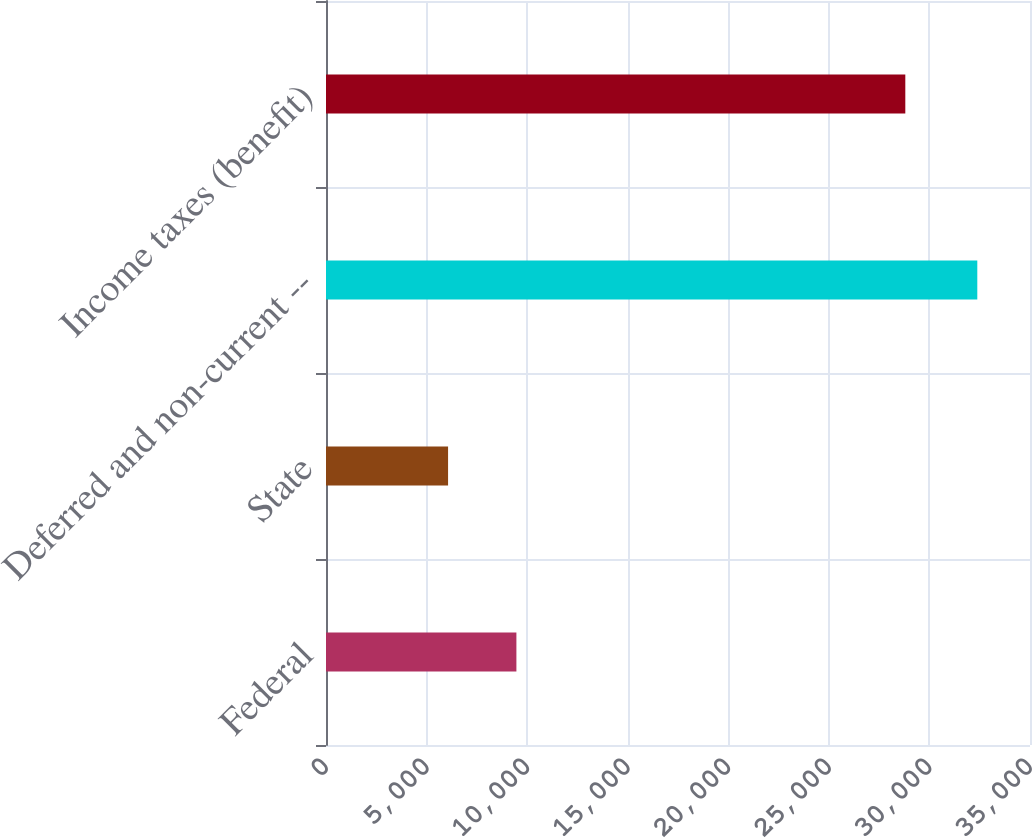Convert chart. <chart><loc_0><loc_0><loc_500><loc_500><bar_chart><fcel>Federal<fcel>State<fcel>Deferred and non-current --<fcel>Income taxes (benefit)<nl><fcel>9466<fcel>6069<fcel>32380<fcel>28801<nl></chart> 